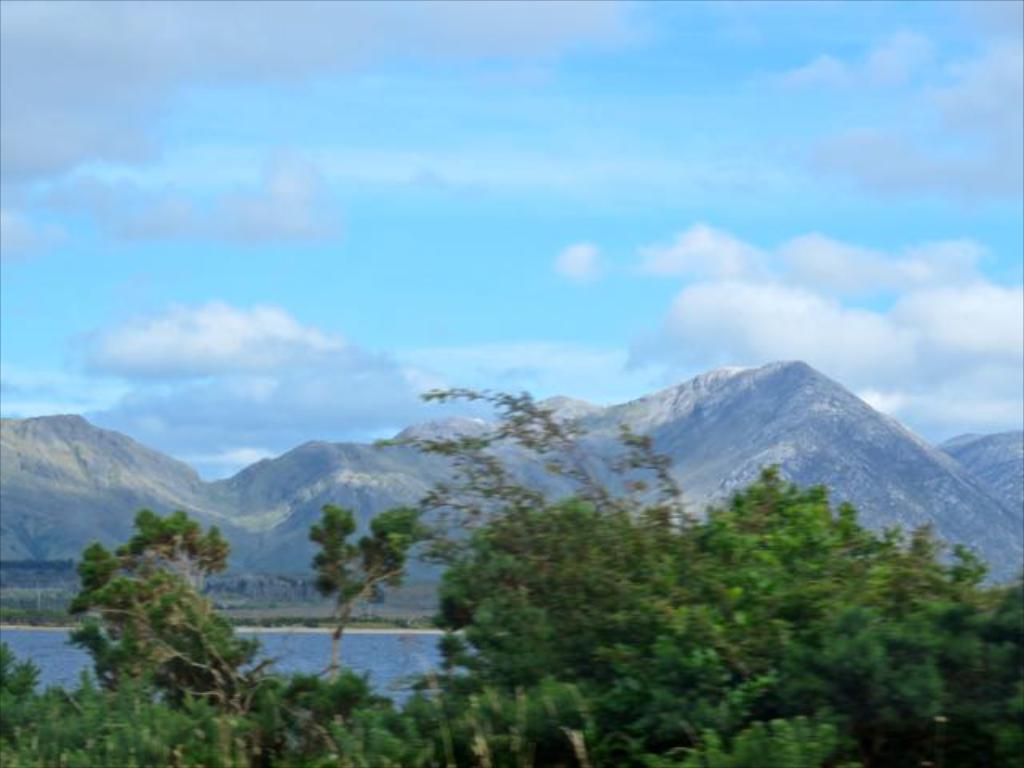Could you give a brief overview of what you see in this image? In this image we can see the surrounding trees, water, i. e.. ocean/river and we can see stony surface such as mountains. And we can see the clouds in the sky. 